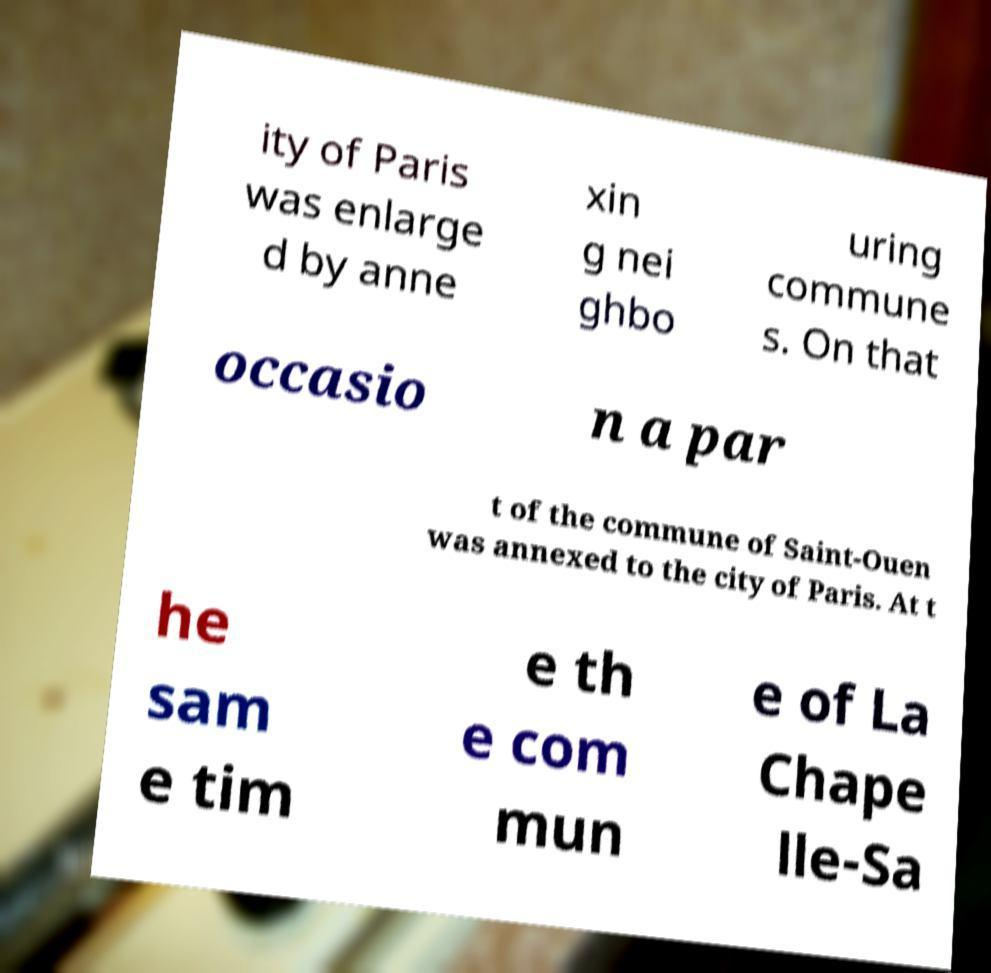Could you assist in decoding the text presented in this image and type it out clearly? ity of Paris was enlarge d by anne xin g nei ghbo uring commune s. On that occasio n a par t of the commune of Saint-Ouen was annexed to the city of Paris. At t he sam e tim e th e com mun e of La Chape lle-Sa 